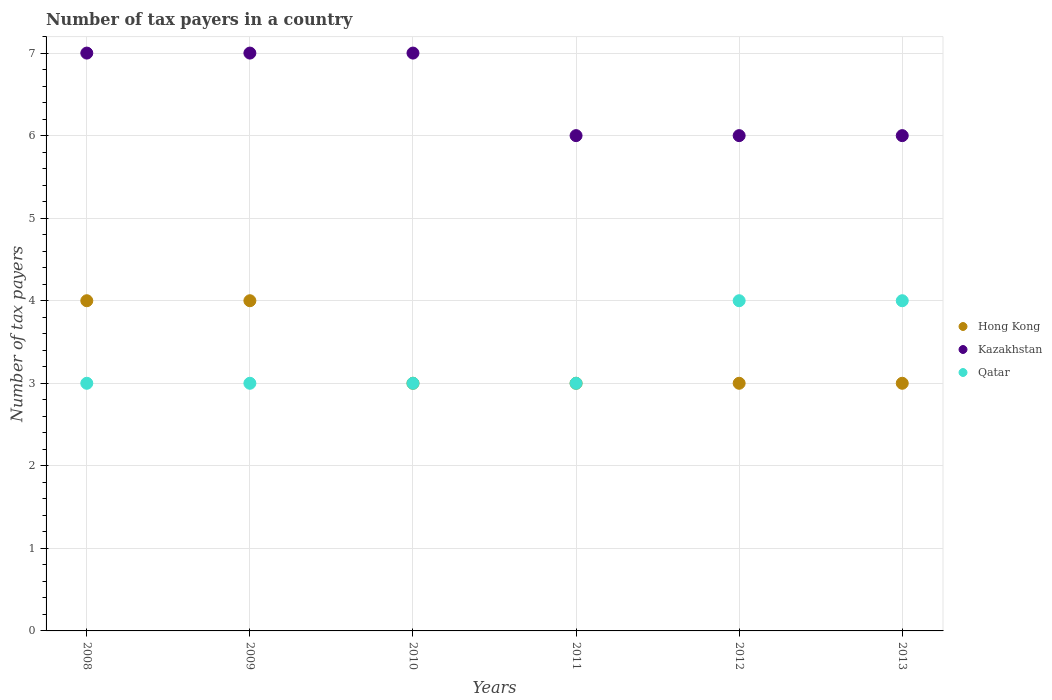Is the number of dotlines equal to the number of legend labels?
Your answer should be very brief. Yes. What is the number of tax payers in in Kazakhstan in 2011?
Offer a terse response. 6. In which year was the number of tax payers in in Qatar maximum?
Your response must be concise. 2012. What is the difference between the number of tax payers in in Kazakhstan in 2009 and that in 2013?
Provide a succinct answer. 1. What is the difference between the number of tax payers in in Qatar in 2011 and the number of tax payers in in Hong Kong in 2010?
Give a very brief answer. 0. What is the average number of tax payers in in Kazakhstan per year?
Your answer should be very brief. 6.5. In the year 2012, what is the difference between the number of tax payers in in Hong Kong and number of tax payers in in Kazakhstan?
Give a very brief answer. -3. Is the difference between the number of tax payers in in Hong Kong in 2009 and 2010 greater than the difference between the number of tax payers in in Kazakhstan in 2009 and 2010?
Provide a short and direct response. Yes. What is the difference between the highest and the lowest number of tax payers in in Hong Kong?
Give a very brief answer. 1. In how many years, is the number of tax payers in in Qatar greater than the average number of tax payers in in Qatar taken over all years?
Provide a succinct answer. 2. Is it the case that in every year, the sum of the number of tax payers in in Kazakhstan and number of tax payers in in Hong Kong  is greater than the number of tax payers in in Qatar?
Make the answer very short. Yes. Is the number of tax payers in in Qatar strictly greater than the number of tax payers in in Kazakhstan over the years?
Your answer should be compact. No. How many years are there in the graph?
Make the answer very short. 6. Does the graph contain any zero values?
Offer a very short reply. No. Does the graph contain grids?
Offer a terse response. Yes. How many legend labels are there?
Your answer should be very brief. 3. How are the legend labels stacked?
Your response must be concise. Vertical. What is the title of the graph?
Your answer should be very brief. Number of tax payers in a country. What is the label or title of the Y-axis?
Provide a succinct answer. Number of tax payers. What is the Number of tax payers of Hong Kong in 2009?
Offer a terse response. 4. What is the Number of tax payers of Kazakhstan in 2010?
Your answer should be compact. 7. What is the Number of tax payers of Hong Kong in 2011?
Your response must be concise. 3. What is the Number of tax payers in Kazakhstan in 2011?
Offer a terse response. 6. What is the Number of tax payers in Hong Kong in 2012?
Offer a very short reply. 3. What is the Number of tax payers of Kazakhstan in 2012?
Your answer should be compact. 6. What is the Number of tax payers of Hong Kong in 2013?
Give a very brief answer. 3. What is the Number of tax payers in Qatar in 2013?
Give a very brief answer. 4. Across all years, what is the maximum Number of tax payers in Kazakhstan?
Keep it short and to the point. 7. Across all years, what is the minimum Number of tax payers in Hong Kong?
Ensure brevity in your answer.  3. Across all years, what is the minimum Number of tax payers of Qatar?
Provide a short and direct response. 3. What is the total Number of tax payers in Hong Kong in the graph?
Offer a terse response. 20. What is the total Number of tax payers of Qatar in the graph?
Offer a very short reply. 20. What is the difference between the Number of tax payers of Kazakhstan in 2008 and that in 2009?
Your answer should be very brief. 0. What is the difference between the Number of tax payers of Hong Kong in 2008 and that in 2010?
Offer a terse response. 1. What is the difference between the Number of tax payers of Kazakhstan in 2008 and that in 2010?
Provide a succinct answer. 0. What is the difference between the Number of tax payers of Qatar in 2008 and that in 2010?
Your answer should be compact. 0. What is the difference between the Number of tax payers of Hong Kong in 2008 and that in 2011?
Offer a terse response. 1. What is the difference between the Number of tax payers in Qatar in 2008 and that in 2011?
Keep it short and to the point. 0. What is the difference between the Number of tax payers of Hong Kong in 2008 and that in 2012?
Your answer should be very brief. 1. What is the difference between the Number of tax payers of Kazakhstan in 2008 and that in 2012?
Ensure brevity in your answer.  1. What is the difference between the Number of tax payers of Qatar in 2008 and that in 2012?
Give a very brief answer. -1. What is the difference between the Number of tax payers of Hong Kong in 2008 and that in 2013?
Keep it short and to the point. 1. What is the difference between the Number of tax payers of Kazakhstan in 2008 and that in 2013?
Give a very brief answer. 1. What is the difference between the Number of tax payers of Qatar in 2008 and that in 2013?
Provide a succinct answer. -1. What is the difference between the Number of tax payers in Hong Kong in 2009 and that in 2010?
Offer a terse response. 1. What is the difference between the Number of tax payers of Kazakhstan in 2009 and that in 2010?
Ensure brevity in your answer.  0. What is the difference between the Number of tax payers of Hong Kong in 2009 and that in 2011?
Your answer should be very brief. 1. What is the difference between the Number of tax payers of Qatar in 2009 and that in 2011?
Provide a succinct answer. 0. What is the difference between the Number of tax payers in Hong Kong in 2009 and that in 2012?
Provide a short and direct response. 1. What is the difference between the Number of tax payers of Kazakhstan in 2009 and that in 2012?
Provide a short and direct response. 1. What is the difference between the Number of tax payers of Hong Kong in 2009 and that in 2013?
Keep it short and to the point. 1. What is the difference between the Number of tax payers of Hong Kong in 2010 and that in 2011?
Give a very brief answer. 0. What is the difference between the Number of tax payers in Qatar in 2010 and that in 2011?
Ensure brevity in your answer.  0. What is the difference between the Number of tax payers in Hong Kong in 2010 and that in 2012?
Make the answer very short. 0. What is the difference between the Number of tax payers of Hong Kong in 2010 and that in 2013?
Make the answer very short. 0. What is the difference between the Number of tax payers of Kazakhstan in 2011 and that in 2012?
Your response must be concise. 0. What is the difference between the Number of tax payers in Qatar in 2011 and that in 2012?
Ensure brevity in your answer.  -1. What is the difference between the Number of tax payers in Hong Kong in 2011 and that in 2013?
Your response must be concise. 0. What is the difference between the Number of tax payers of Kazakhstan in 2011 and that in 2013?
Provide a succinct answer. 0. What is the difference between the Number of tax payers of Kazakhstan in 2012 and that in 2013?
Offer a very short reply. 0. What is the difference between the Number of tax payers of Qatar in 2012 and that in 2013?
Make the answer very short. 0. What is the difference between the Number of tax payers in Hong Kong in 2008 and the Number of tax payers in Qatar in 2009?
Provide a short and direct response. 1. What is the difference between the Number of tax payers in Hong Kong in 2008 and the Number of tax payers in Kazakhstan in 2010?
Your response must be concise. -3. What is the difference between the Number of tax payers of Kazakhstan in 2008 and the Number of tax payers of Qatar in 2010?
Your answer should be compact. 4. What is the difference between the Number of tax payers of Hong Kong in 2008 and the Number of tax payers of Qatar in 2011?
Make the answer very short. 1. What is the difference between the Number of tax payers in Kazakhstan in 2008 and the Number of tax payers in Qatar in 2011?
Make the answer very short. 4. What is the difference between the Number of tax payers of Hong Kong in 2008 and the Number of tax payers of Kazakhstan in 2012?
Give a very brief answer. -2. What is the difference between the Number of tax payers in Hong Kong in 2008 and the Number of tax payers in Qatar in 2012?
Offer a terse response. 0. What is the difference between the Number of tax payers in Kazakhstan in 2009 and the Number of tax payers in Qatar in 2010?
Offer a terse response. 4. What is the difference between the Number of tax payers in Hong Kong in 2009 and the Number of tax payers in Kazakhstan in 2011?
Offer a terse response. -2. What is the difference between the Number of tax payers in Hong Kong in 2009 and the Number of tax payers in Qatar in 2011?
Offer a terse response. 1. What is the difference between the Number of tax payers in Hong Kong in 2009 and the Number of tax payers in Kazakhstan in 2012?
Your answer should be compact. -2. What is the difference between the Number of tax payers in Hong Kong in 2009 and the Number of tax payers in Qatar in 2012?
Your answer should be compact. 0. What is the difference between the Number of tax payers in Hong Kong in 2009 and the Number of tax payers in Kazakhstan in 2013?
Make the answer very short. -2. What is the difference between the Number of tax payers of Kazakhstan in 2010 and the Number of tax payers of Qatar in 2012?
Ensure brevity in your answer.  3. What is the difference between the Number of tax payers in Kazakhstan in 2010 and the Number of tax payers in Qatar in 2013?
Your response must be concise. 3. What is the difference between the Number of tax payers of Hong Kong in 2011 and the Number of tax payers of Qatar in 2012?
Offer a terse response. -1. What is the difference between the Number of tax payers in Kazakhstan in 2011 and the Number of tax payers in Qatar in 2012?
Provide a succinct answer. 2. What is the difference between the Number of tax payers of Kazakhstan in 2012 and the Number of tax payers of Qatar in 2013?
Your answer should be very brief. 2. What is the average Number of tax payers in Hong Kong per year?
Ensure brevity in your answer.  3.33. What is the average Number of tax payers of Qatar per year?
Provide a short and direct response. 3.33. In the year 2008, what is the difference between the Number of tax payers in Hong Kong and Number of tax payers in Kazakhstan?
Provide a succinct answer. -3. In the year 2009, what is the difference between the Number of tax payers of Hong Kong and Number of tax payers of Kazakhstan?
Ensure brevity in your answer.  -3. In the year 2009, what is the difference between the Number of tax payers of Hong Kong and Number of tax payers of Qatar?
Provide a succinct answer. 1. In the year 2010, what is the difference between the Number of tax payers in Hong Kong and Number of tax payers in Qatar?
Your response must be concise. 0. In the year 2012, what is the difference between the Number of tax payers in Kazakhstan and Number of tax payers in Qatar?
Your answer should be compact. 2. In the year 2013, what is the difference between the Number of tax payers in Hong Kong and Number of tax payers in Qatar?
Offer a terse response. -1. What is the ratio of the Number of tax payers of Hong Kong in 2008 to that in 2010?
Your response must be concise. 1.33. What is the ratio of the Number of tax payers of Kazakhstan in 2008 to that in 2010?
Make the answer very short. 1. What is the ratio of the Number of tax payers of Kazakhstan in 2008 to that in 2011?
Give a very brief answer. 1.17. What is the ratio of the Number of tax payers of Kazakhstan in 2008 to that in 2013?
Keep it short and to the point. 1.17. What is the ratio of the Number of tax payers in Qatar in 2008 to that in 2013?
Give a very brief answer. 0.75. What is the ratio of the Number of tax payers of Hong Kong in 2009 to that in 2010?
Your answer should be very brief. 1.33. What is the ratio of the Number of tax payers of Kazakhstan in 2009 to that in 2010?
Offer a very short reply. 1. What is the ratio of the Number of tax payers in Qatar in 2009 to that in 2010?
Provide a short and direct response. 1. What is the ratio of the Number of tax payers of Kazakhstan in 2009 to that in 2011?
Give a very brief answer. 1.17. What is the ratio of the Number of tax payers of Hong Kong in 2009 to that in 2012?
Offer a terse response. 1.33. What is the ratio of the Number of tax payers of Qatar in 2009 to that in 2012?
Give a very brief answer. 0.75. What is the ratio of the Number of tax payers of Hong Kong in 2009 to that in 2013?
Ensure brevity in your answer.  1.33. What is the ratio of the Number of tax payers of Qatar in 2010 to that in 2011?
Offer a terse response. 1. What is the ratio of the Number of tax payers in Hong Kong in 2010 to that in 2013?
Your response must be concise. 1. What is the ratio of the Number of tax payers of Kazakhstan in 2010 to that in 2013?
Provide a succinct answer. 1.17. What is the ratio of the Number of tax payers in Hong Kong in 2011 to that in 2012?
Provide a short and direct response. 1. What is the ratio of the Number of tax payers in Kazakhstan in 2011 to that in 2012?
Ensure brevity in your answer.  1. What is the ratio of the Number of tax payers of Qatar in 2011 to that in 2012?
Make the answer very short. 0.75. What is the ratio of the Number of tax payers of Hong Kong in 2012 to that in 2013?
Offer a terse response. 1. What is the ratio of the Number of tax payers of Kazakhstan in 2012 to that in 2013?
Give a very brief answer. 1. What is the ratio of the Number of tax payers of Qatar in 2012 to that in 2013?
Your answer should be very brief. 1. What is the difference between the highest and the lowest Number of tax payers in Hong Kong?
Keep it short and to the point. 1. 